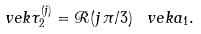Convert formula to latex. <formula><loc_0><loc_0><loc_500><loc_500>\ v e k { \tau } ^ { ( j ) } _ { 2 } = \mathcal { R } ( j \, \pi / 3 ) \, \ v e k { a } _ { 1 } .</formula> 